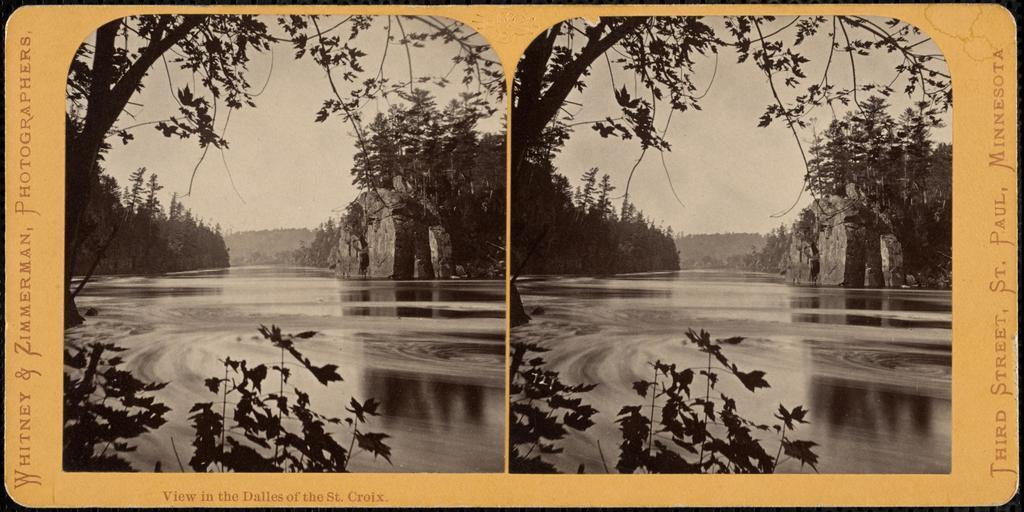In one or two sentences, can you explain what this image depicts? This is a collage image, and here we can see trees, rock and at the bottom, there is water. 